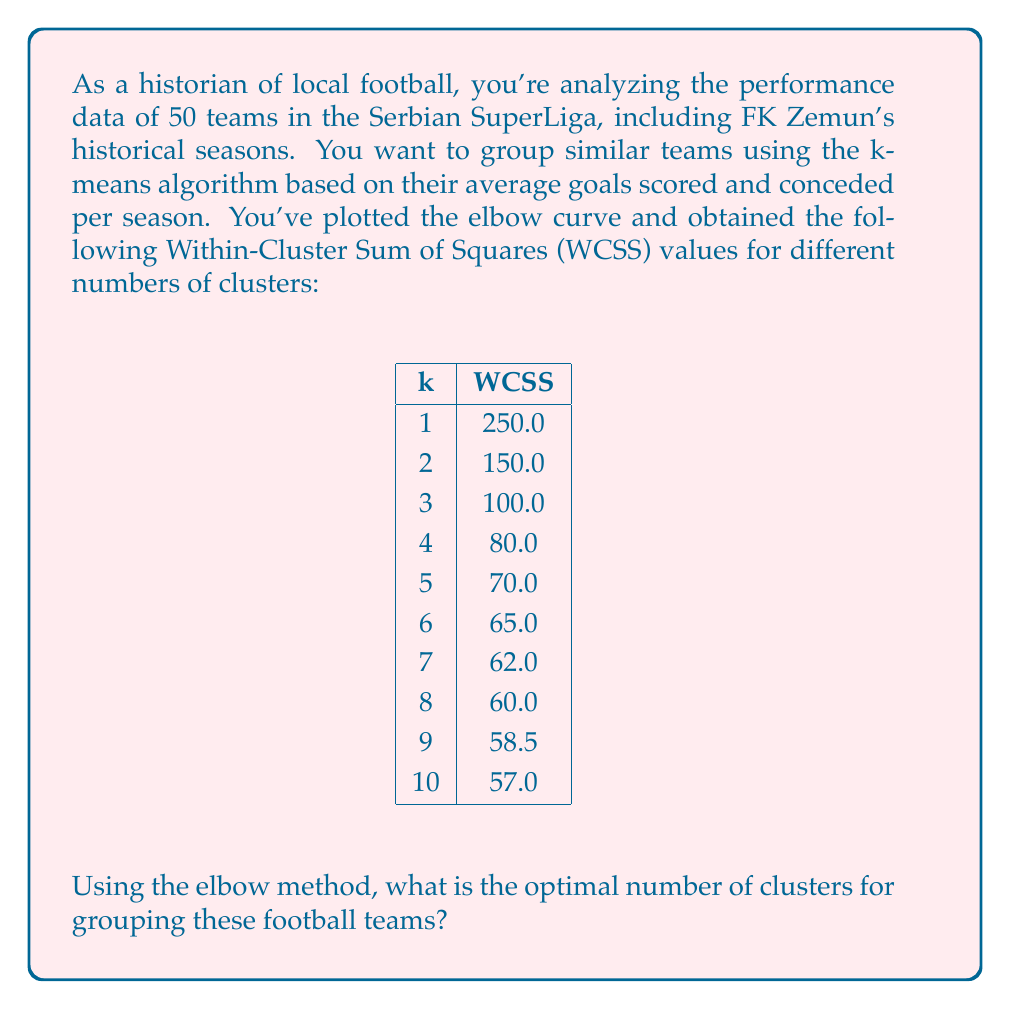What is the answer to this math problem? To determine the optimal number of clusters using the elbow method, we need to analyze the Within-Cluster Sum of Squares (WCSS) values for different numbers of clusters (k). The elbow method involves looking for the "elbow point" in the curve, where the rate of decrease in WCSS begins to level off.

Let's go through the process step-by-step:

1. Plot the WCSS values against the number of clusters (k). This forms the elbow curve.

2. Observe the curve for a point where the rate of decrease in WCSS slows down significantly. This point is often referred to as the "elbow" of the curve.

3. In this case, we can see that:
   - The WCSS decreases rapidly from k=1 to k=3
   - There's still a noticeable decrease from k=3 to k=4
   - The decrease becomes much less pronounced after k=4

4. The elbow point is where the curve starts to level off, which in this case appears to be at k=4.

5. After k=4, the decrease in WCSS is minimal, indicating that additional clusters don't provide significant improvement in the model's performance.

6. While k=5 and beyond might provide slightly lower WCSS values, the improvement is marginal compared to the increase in model complexity.

Therefore, based on the elbow method, the optimal number of clusters for grouping these football teams is 4. This would allow for a good balance between minimizing within-cluster variation and avoiding overfitting with too many clusters.

For FK Zemun and other local teams, this clustering could reveal interesting patterns in playing styles or performance levels across different seasons in the Serbian SuperLiga.
Answer: 4 clusters 